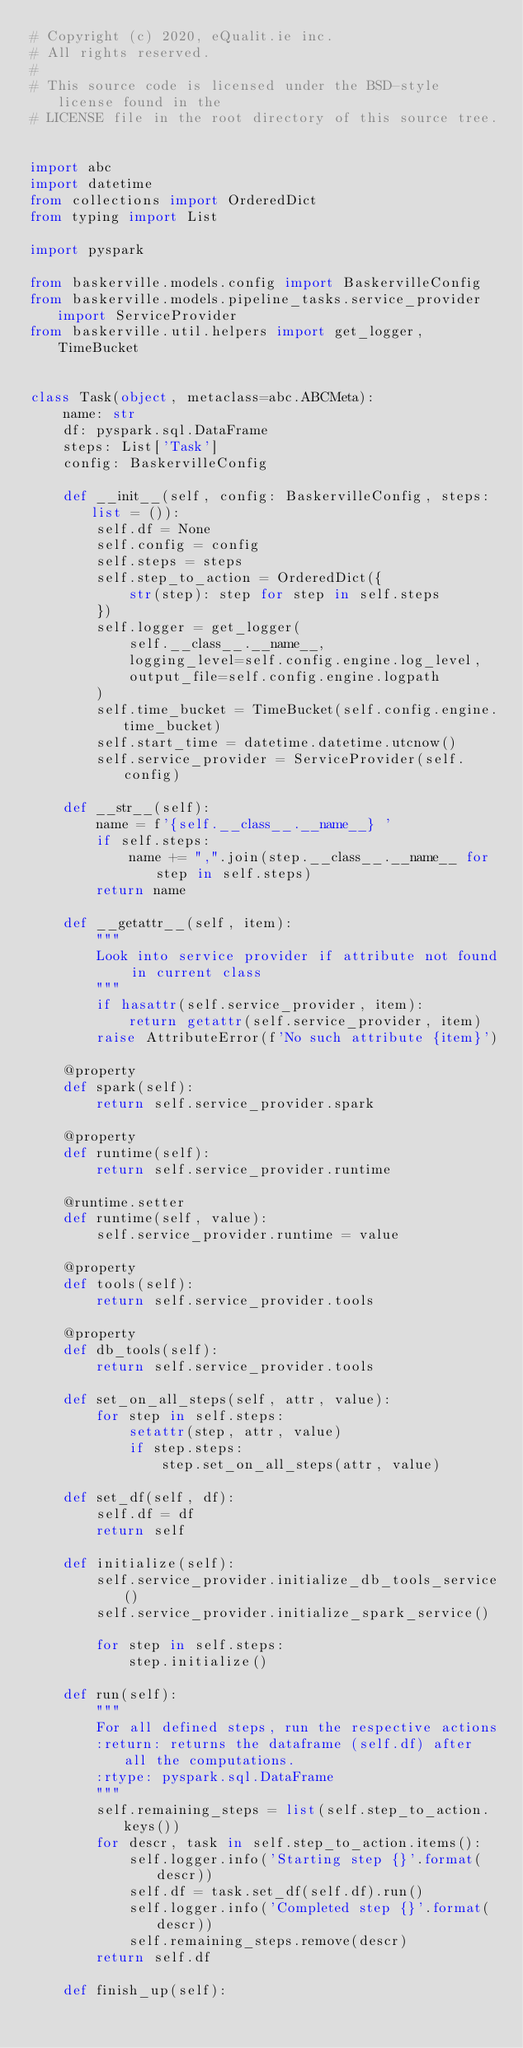Convert code to text. <code><loc_0><loc_0><loc_500><loc_500><_Python_># Copyright (c) 2020, eQualit.ie inc.
# All rights reserved.
#
# This source code is licensed under the BSD-style license found in the
# LICENSE file in the root directory of this source tree.


import abc
import datetime
from collections import OrderedDict
from typing import List

import pyspark

from baskerville.models.config import BaskervilleConfig
from baskerville.models.pipeline_tasks.service_provider import ServiceProvider
from baskerville.util.helpers import get_logger, TimeBucket


class Task(object, metaclass=abc.ABCMeta):
    name: str
    df: pyspark.sql.DataFrame
    steps: List['Task']
    config: BaskervilleConfig

    def __init__(self, config: BaskervilleConfig, steps: list = ()):
        self.df = None
        self.config = config
        self.steps = steps
        self.step_to_action = OrderedDict({
            str(step): step for step in self.steps
        })
        self.logger = get_logger(
            self.__class__.__name__,
            logging_level=self.config.engine.log_level,
            output_file=self.config.engine.logpath
        )
        self.time_bucket = TimeBucket(self.config.engine.time_bucket)
        self.start_time = datetime.datetime.utcnow()
        self.service_provider = ServiceProvider(self.config)

    def __str__(self):
        name = f'{self.__class__.__name__} '
        if self.steps:
            name += ",".join(step.__class__.__name__ for step in self.steps)
        return name

    def __getattr__(self, item):
        """
        Look into service provider if attribute not found in current class
        """
        if hasattr(self.service_provider, item):
            return getattr(self.service_provider, item)
        raise AttributeError(f'No such attribute {item}')

    @property
    def spark(self):
        return self.service_provider.spark

    @property
    def runtime(self):
        return self.service_provider.runtime

    @runtime.setter
    def runtime(self, value):
        self.service_provider.runtime = value

    @property
    def tools(self):
        return self.service_provider.tools

    @property
    def db_tools(self):
        return self.service_provider.tools

    def set_on_all_steps(self, attr, value):
        for step in self.steps:
            setattr(step, attr, value)
            if step.steps:
                step.set_on_all_steps(attr, value)

    def set_df(self, df):
        self.df = df
        return self

    def initialize(self):
        self.service_provider.initialize_db_tools_service()
        self.service_provider.initialize_spark_service()

        for step in self.steps:
            step.initialize()

    def run(self):
        """
        For all defined steps, run the respective actions
        :return: returns the dataframe (self.df) after all the computations.
        :rtype: pyspark.sql.DataFrame
        """
        self.remaining_steps = list(self.step_to_action.keys())
        for descr, task in self.step_to_action.items():
            self.logger.info('Starting step {}'.format(descr))
            self.df = task.set_df(self.df).run()
            self.logger.info('Completed step {}'.format(descr))
            self.remaining_steps.remove(descr)
        return self.df

    def finish_up(self):</code> 